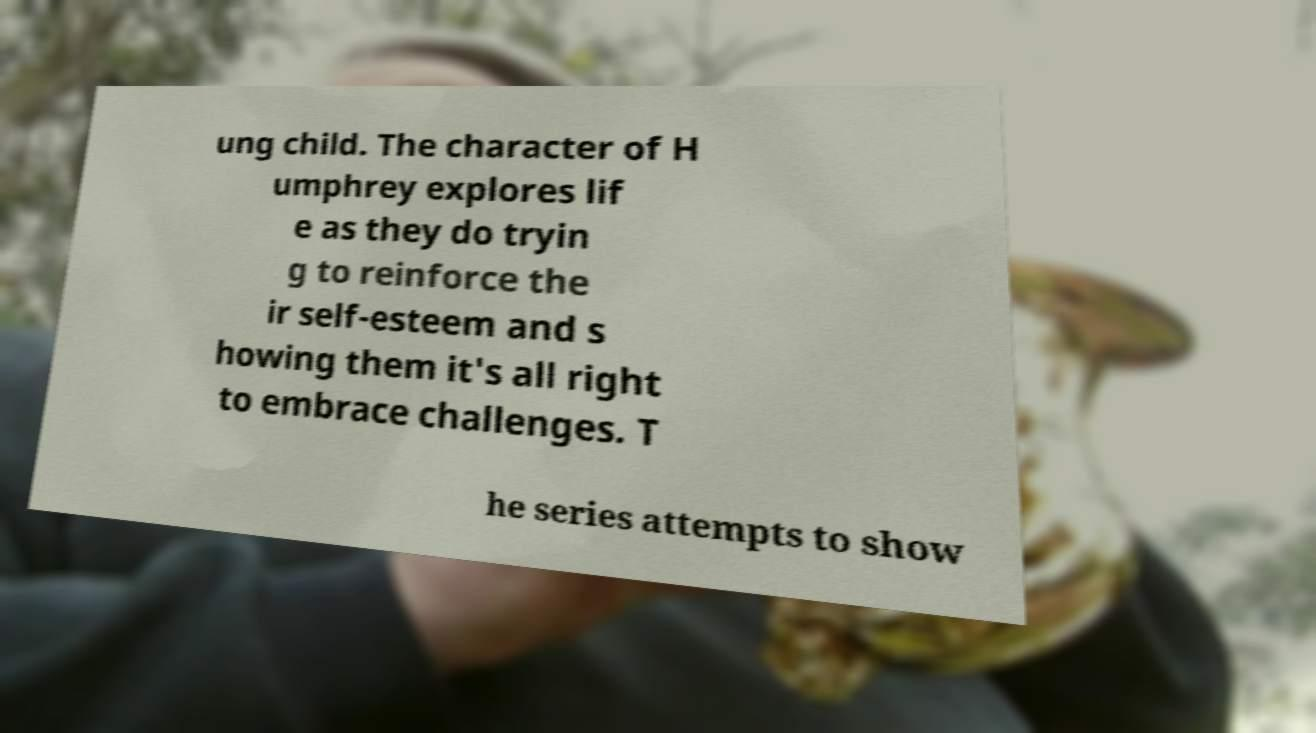What messages or text are displayed in this image? I need them in a readable, typed format. ung child. The character of H umphrey explores lif e as they do tryin g to reinforce the ir self-esteem and s howing them it's all right to embrace challenges. T he series attempts to show 